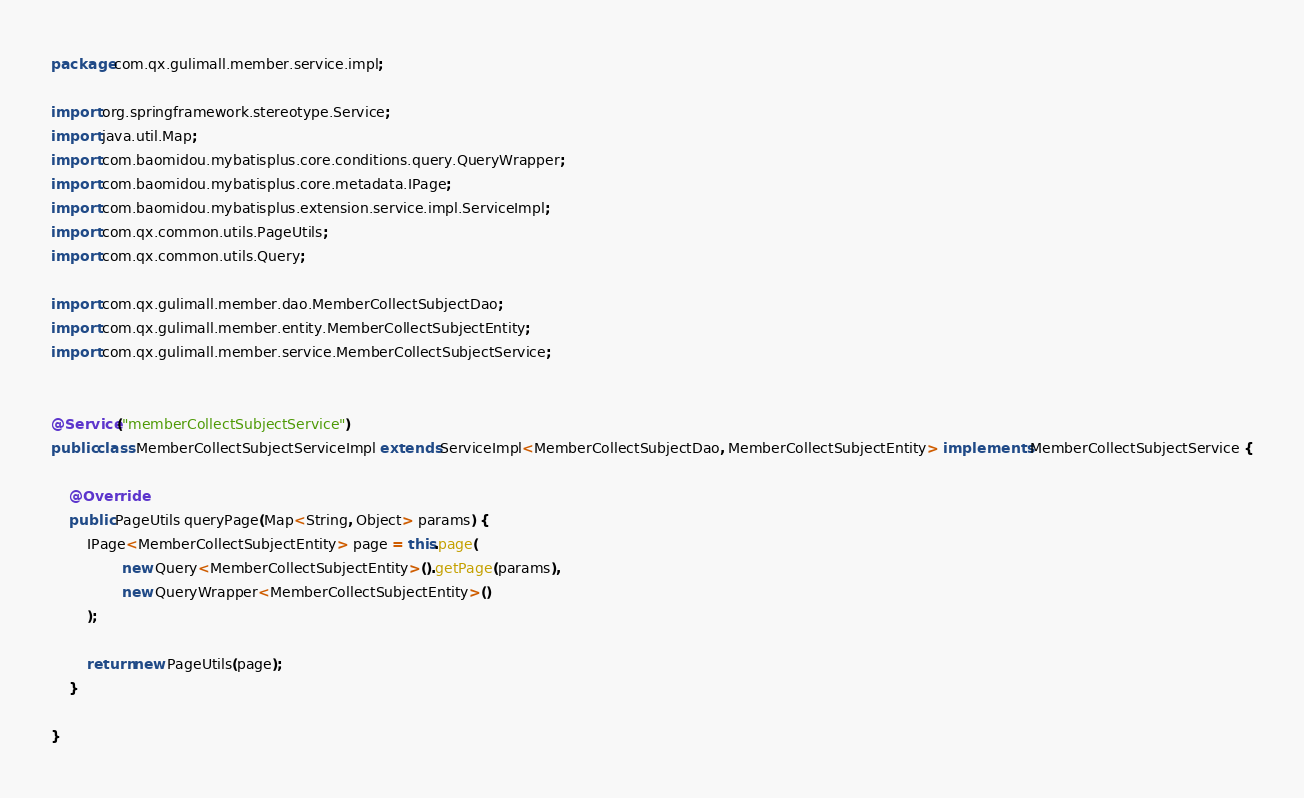<code> <loc_0><loc_0><loc_500><loc_500><_Java_>package com.qx.gulimall.member.service.impl;

import org.springframework.stereotype.Service;
import java.util.Map;
import com.baomidou.mybatisplus.core.conditions.query.QueryWrapper;
import com.baomidou.mybatisplus.core.metadata.IPage;
import com.baomidou.mybatisplus.extension.service.impl.ServiceImpl;
import com.qx.common.utils.PageUtils;
import com.qx.common.utils.Query;

import com.qx.gulimall.member.dao.MemberCollectSubjectDao;
import com.qx.gulimall.member.entity.MemberCollectSubjectEntity;
import com.qx.gulimall.member.service.MemberCollectSubjectService;


@Service("memberCollectSubjectService")
public class MemberCollectSubjectServiceImpl extends ServiceImpl<MemberCollectSubjectDao, MemberCollectSubjectEntity> implements MemberCollectSubjectService {

    @Override
    public PageUtils queryPage(Map<String, Object> params) {
        IPage<MemberCollectSubjectEntity> page = this.page(
                new Query<MemberCollectSubjectEntity>().getPage(params),
                new QueryWrapper<MemberCollectSubjectEntity>()
        );

        return new PageUtils(page);
    }

}</code> 